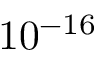Convert formula to latex. <formula><loc_0><loc_0><loc_500><loc_500>1 0 ^ { - 1 6 }</formula> 